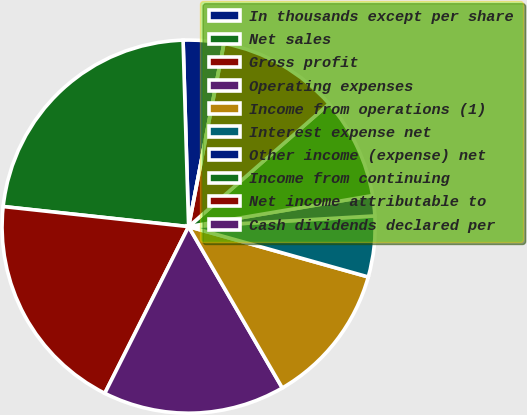<chart> <loc_0><loc_0><loc_500><loc_500><pie_chart><fcel>In thousands except per share<fcel>Net sales<fcel>Gross profit<fcel>Operating expenses<fcel>Income from operations (1)<fcel>Interest expense net<fcel>Other income (expense) net<fcel>Income from continuing<fcel>Net income attributable to<fcel>Cash dividends declared per<nl><fcel>3.51%<fcel>22.81%<fcel>19.3%<fcel>15.79%<fcel>12.28%<fcel>5.26%<fcel>1.75%<fcel>8.77%<fcel>10.53%<fcel>0.0%<nl></chart> 